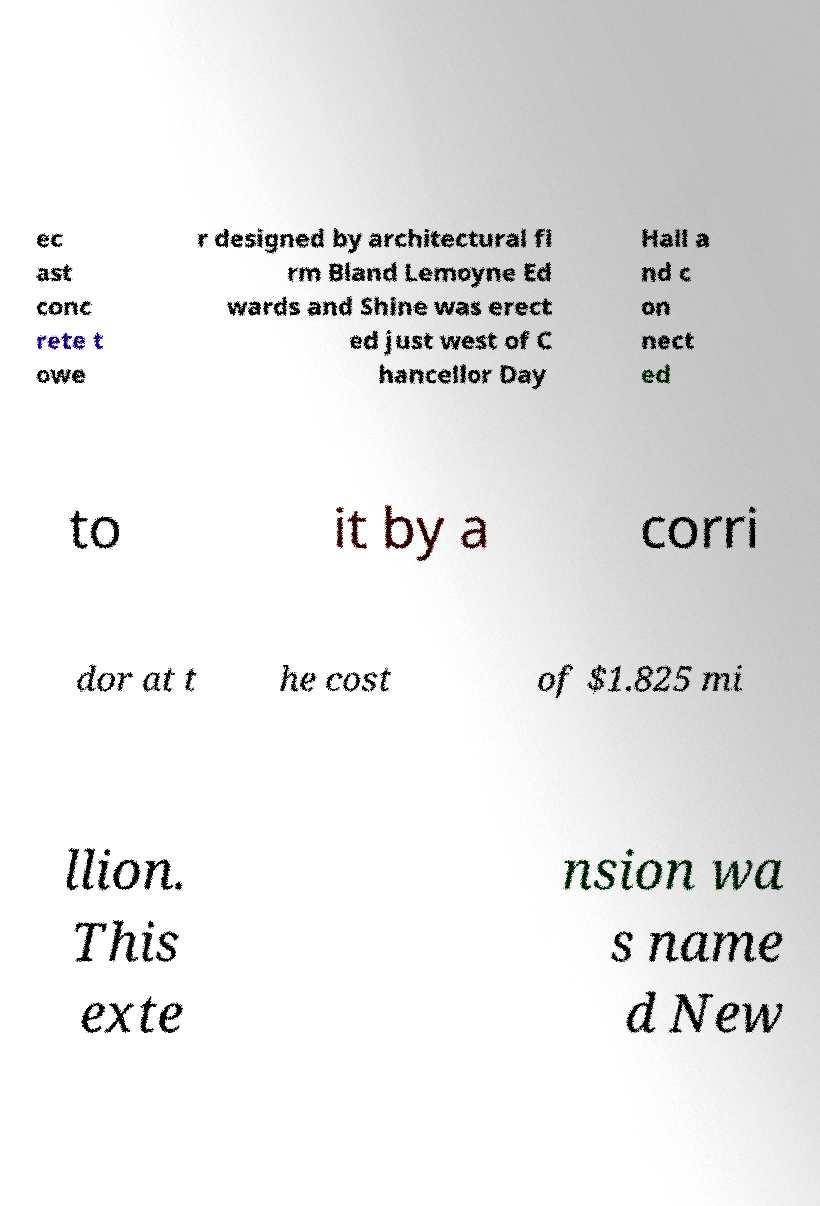Please read and relay the text visible in this image. What does it say? ec ast conc rete t owe r designed by architectural fi rm Bland Lemoyne Ed wards and Shine was erect ed just west of C hancellor Day Hall a nd c on nect ed to it by a corri dor at t he cost of $1.825 mi llion. This exte nsion wa s name d New 